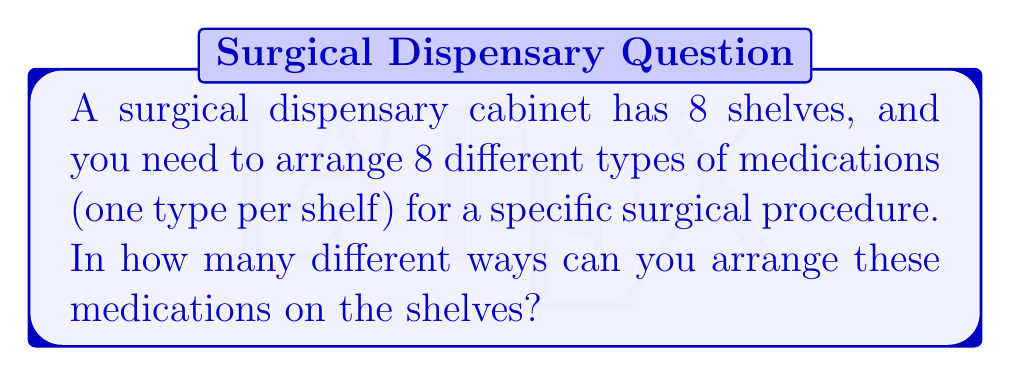Could you help me with this problem? Let's approach this step-by-step:

1) This problem is essentially asking about the number of ways to arrange 8 distinct objects (medications) in 8 distinct positions (shelves).

2) This is a classic permutation problem. We are arranging all 8 medications, and the order matters (since each medication is on a specific shelf).

3) The formula for permutations of n distinct objects is:

   $$P(n) = n!$$

   Where $n!$ represents the factorial of n.

4) In this case, $n = 8$, so we need to calculate $8!$

5) Let's expand this:
   
   $$8! = 8 \times 7 \times 6 \times 5 \times 4 \times 3 \times 2 \times 1$$

6) Calculating this out:
   
   $$8! = 40,320$$

Therefore, there are 40,320 different ways to arrange the 8 medications on the 8 shelves.
Answer: $40,320$ 